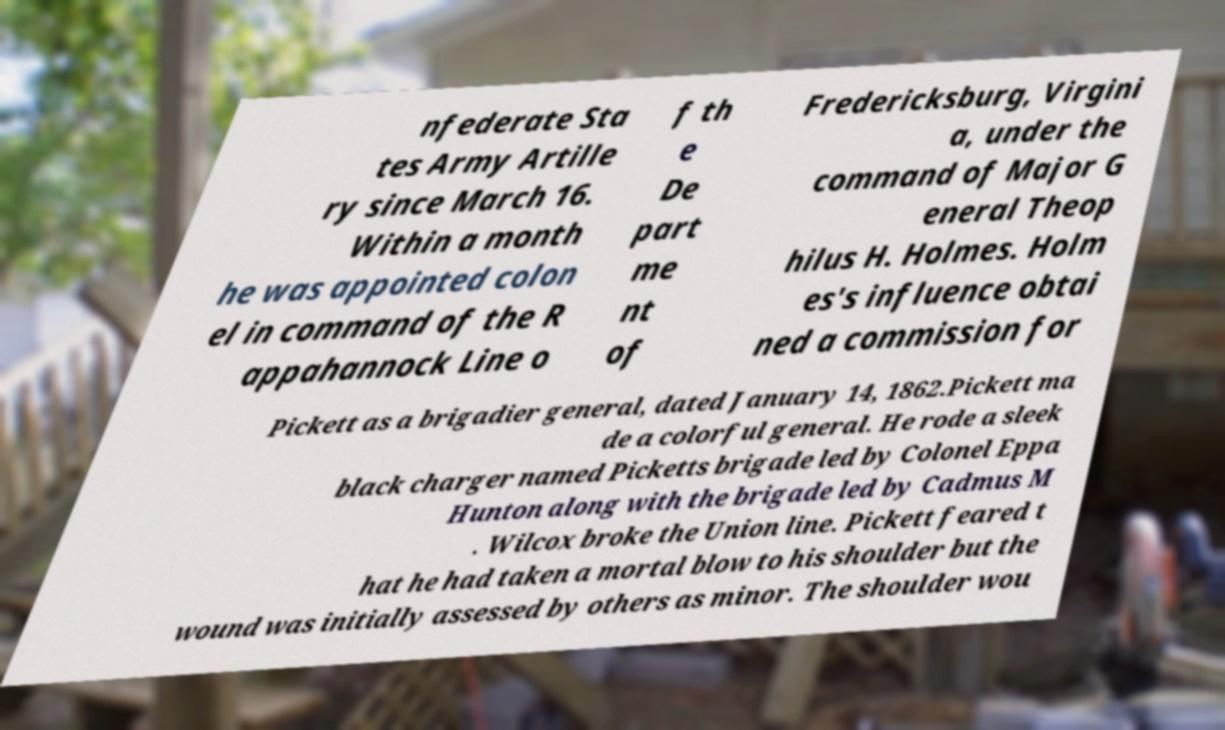Could you assist in decoding the text presented in this image and type it out clearly? nfederate Sta tes Army Artille ry since March 16. Within a month he was appointed colon el in command of the R appahannock Line o f th e De part me nt of Fredericksburg, Virgini a, under the command of Major G eneral Theop hilus H. Holmes. Holm es's influence obtai ned a commission for Pickett as a brigadier general, dated January 14, 1862.Pickett ma de a colorful general. He rode a sleek black charger named Picketts brigade led by Colonel Eppa Hunton along with the brigade led by Cadmus M . Wilcox broke the Union line. Pickett feared t hat he had taken a mortal blow to his shoulder but the wound was initially assessed by others as minor. The shoulder wou 